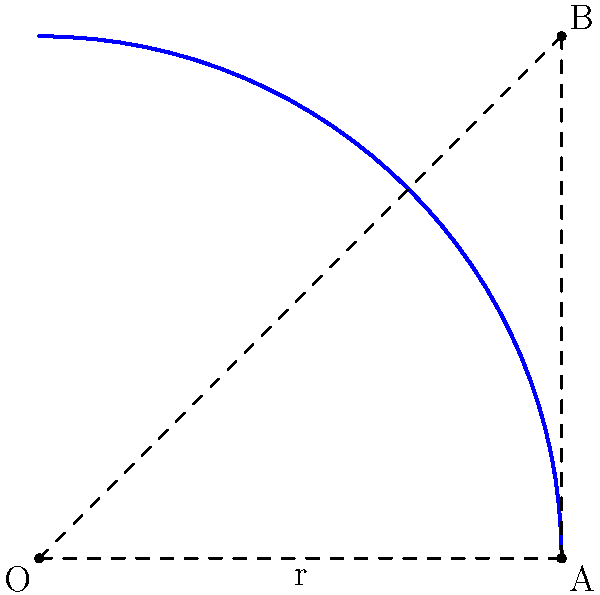During a defensive driving course, you're teaching about the importance of anticipating a vehicle's path during turns. Using the diagram, which represents a car's turning path as a quarter circle, estimate the length of the curved path from point A to point B. Given that the radius (r) of the turn is 20 meters, what is the approximate distance the car travels along the curve? To solve this problem, we'll follow these steps:

1) Recognize that the curve from A to B forms a quarter circle (90-degree arc).

2) Recall the formula for the length of an arc:
   Arc length = $\frac{\theta}{360^\circ} \cdot 2\pi r$
   Where $\theta$ is the central angle in degrees, and $r$ is the radius.

3) In this case:
   $\theta = 90^\circ$ (quarter circle)
   $r = 20$ meters

4) Substitute these values into the formula:
   Arc length = $\frac{90^\circ}{360^\circ} \cdot 2\pi \cdot 20$

5) Simplify:
   Arc length = $\frac{1}{4} \cdot 2\pi \cdot 20$
               = $\frac{1}{2} \pi \cdot 20$
               = $10\pi$ meters

6) Calculate the approximate value:
   $10\pi \approx 31.42$ meters

Therefore, the car travels approximately 31.42 meters along the curved path from A to B.
Answer: $10\pi$ meters (approximately 31.42 meters) 